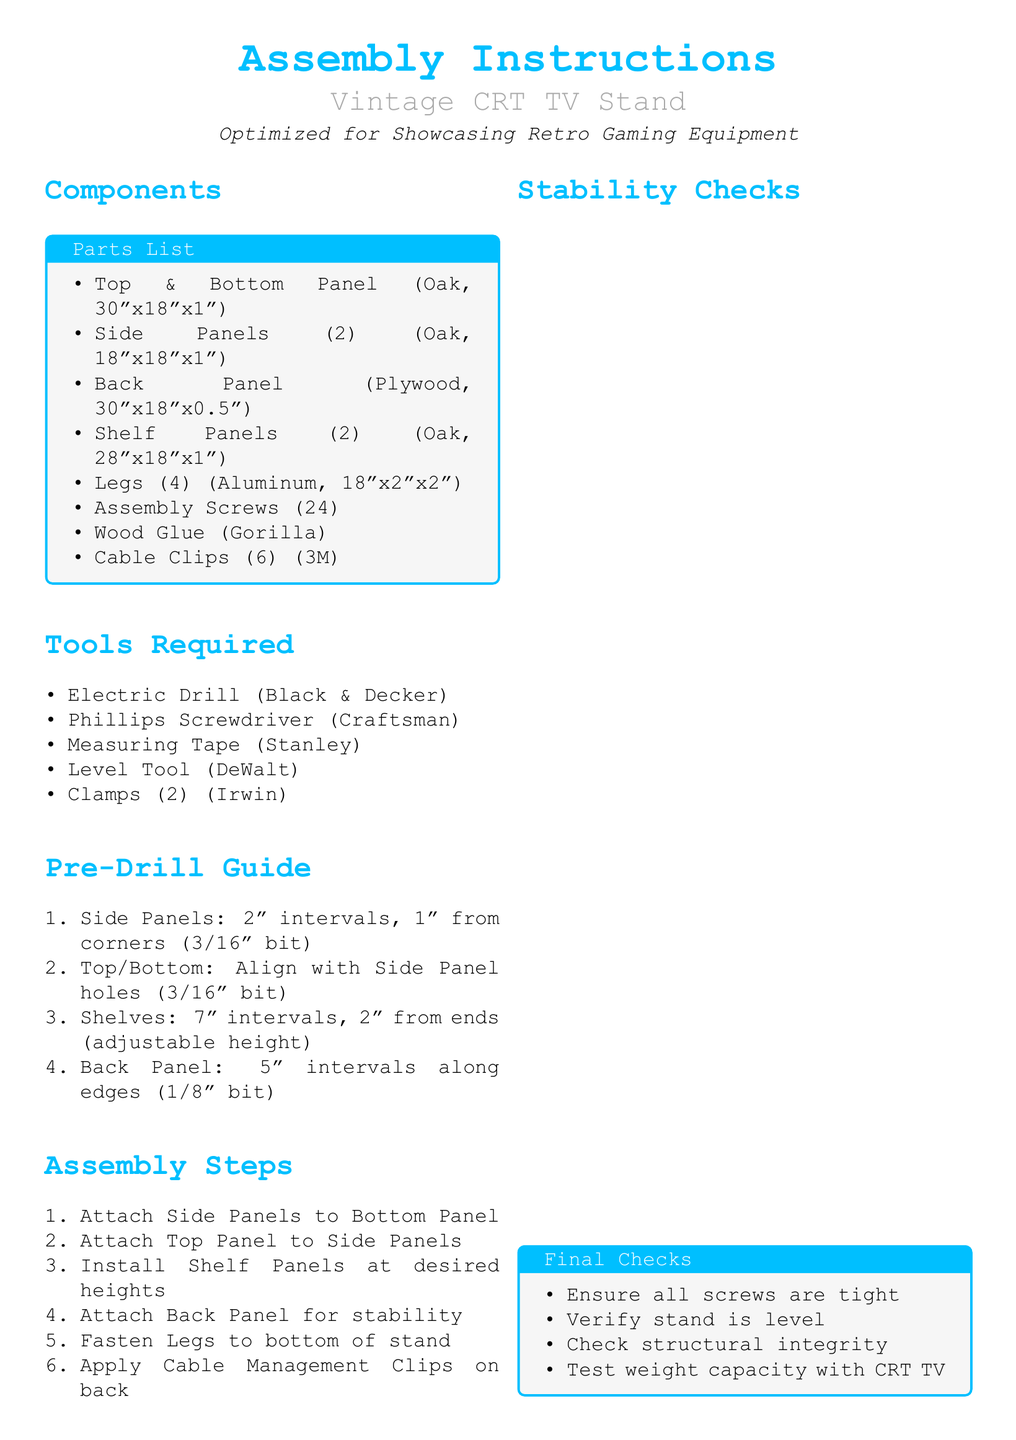What is the size of the Top & Bottom Panel? The size of the Top & Bottom Panel is given as 30"x18"x1".
Answer: 30"x18"x1" How many Legs are included in the parts list? The parts list states that there are 4 Legs included.
Answer: 4 What type of wood is used for the Side Panels? The type of wood specified for the Side Panels is Oak.
Answer: Oak What is the distance for pre-drilling Side Panels? The document instructs to pre-drill Side Panels at 2" intervals, 1" from corners.
Answer: 2" intervals, 1" from corners Which tool is required for checking if the stand is level? The tool needed for checking the level of the stand is a Level Tool.
Answer: Level Tool How many Cable Clips are included? The document states that 6 Cable Clips are included.
Answer: 6 What should be ensured during Stability Checks? Stability Checks require ensuring all screws are tight.
Answer: All screws are tight What is the material of the Back Panel? The Back Panel is made of Plywood.
Answer: Plywood What is the purpose of the assembly diagram section? The assembly diagram section is reserved for a detailed assembly diagram of the TV stand.
Answer: Detailed assembly diagram of the TV stand 